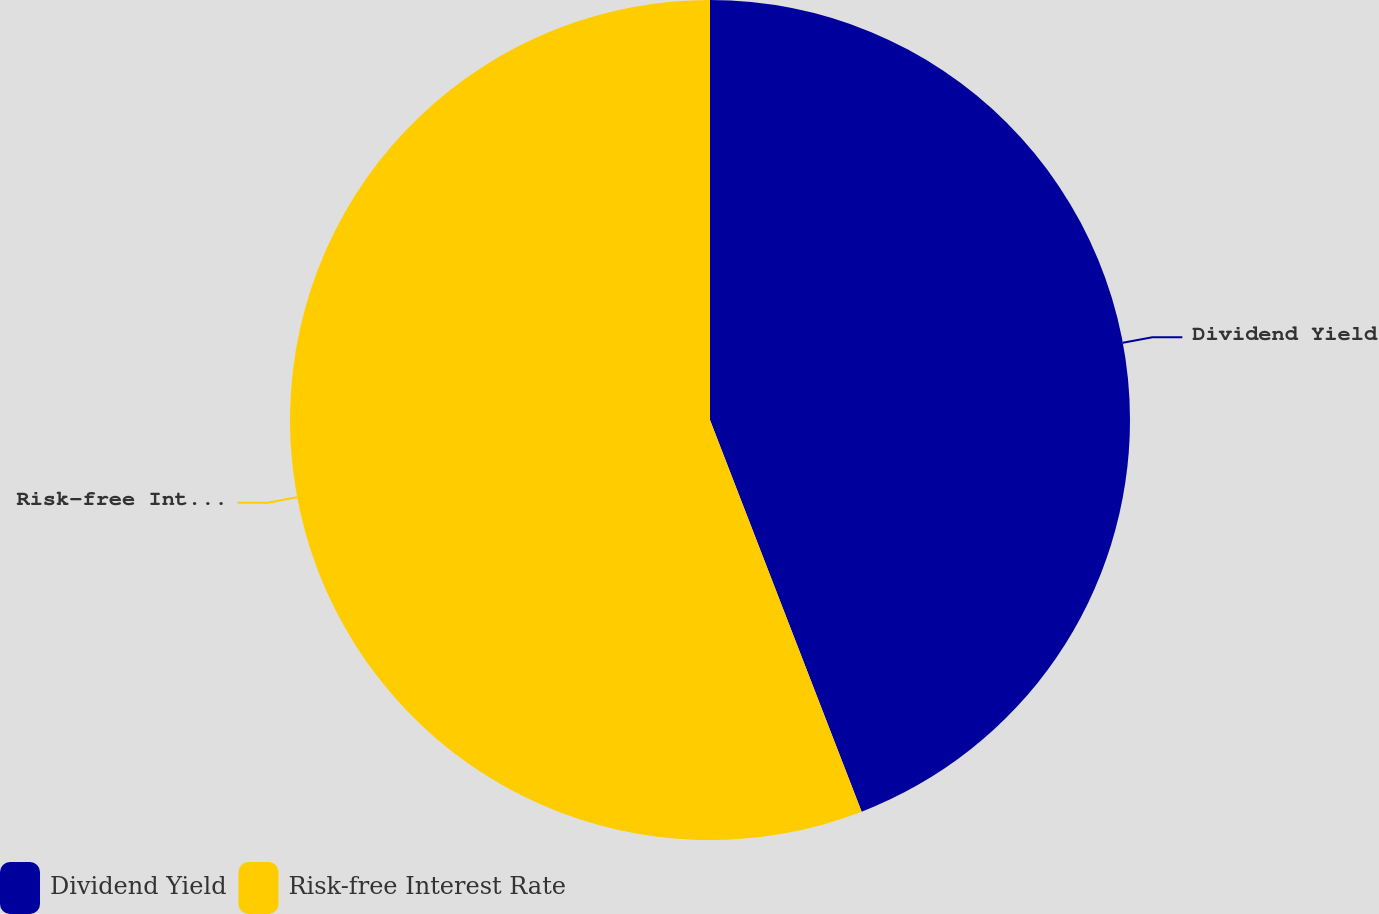Convert chart to OTSL. <chart><loc_0><loc_0><loc_500><loc_500><pie_chart><fcel>Dividend Yield<fcel>Risk-free Interest Rate<nl><fcel>44.12%<fcel>55.88%<nl></chart> 